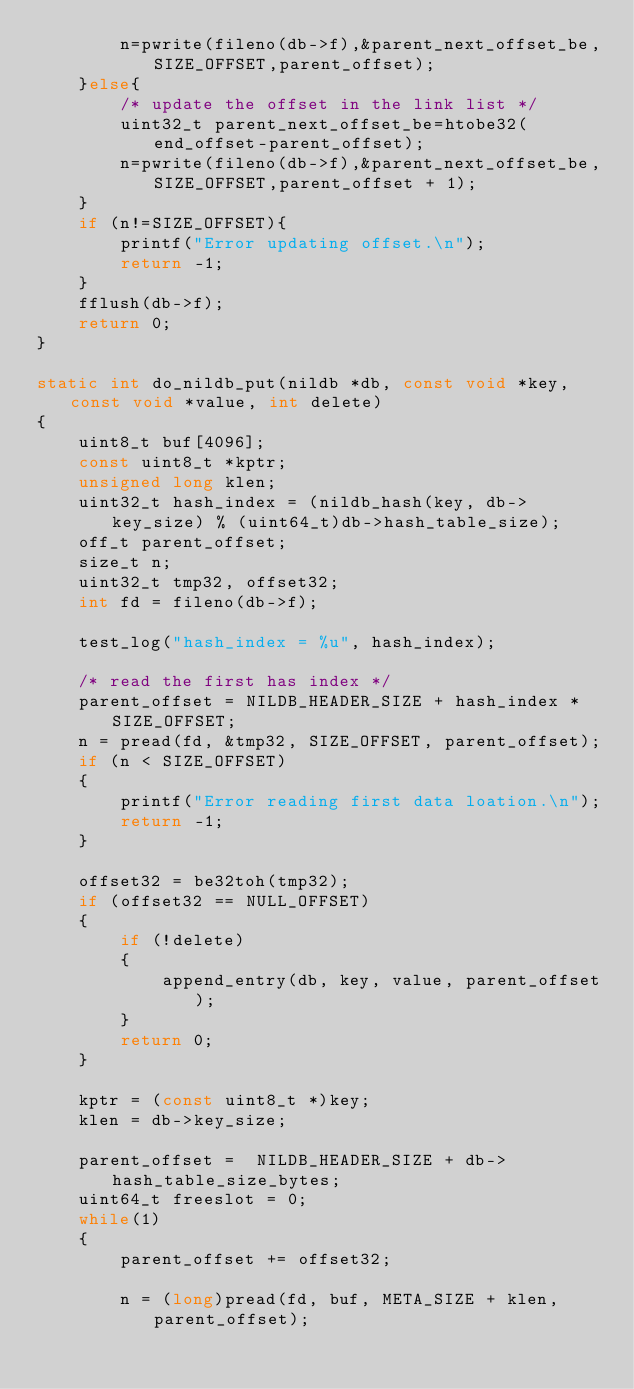Convert code to text. <code><loc_0><loc_0><loc_500><loc_500><_C_>		n=pwrite(fileno(db->f),&parent_next_offset_be,SIZE_OFFSET,parent_offset);
	}else{
		/* update the offset in the link list */
		uint32_t parent_next_offset_be=htobe32(end_offset-parent_offset);
		n=pwrite(fileno(db->f),&parent_next_offset_be,SIZE_OFFSET,parent_offset + 1);
	}
	if (n!=SIZE_OFFSET){
		printf("Error updating offset.\n");
		return -1;
	}
	fflush(db->f);
	return 0;
}

static int do_nildb_put(nildb *db, const void *key, const void *value, int delete)
{
	uint8_t buf[4096];
	const uint8_t *kptr;
	unsigned long klen;
	uint32_t hash_index = (nildb_hash(key, db->key_size) % (uint64_t)db->hash_table_size);
	off_t parent_offset;
	size_t n;
	uint32_t tmp32, offset32;
	int fd = fileno(db->f);

	test_log("hash_index = %u", hash_index);

	/* read the first has index */
	parent_offset = NILDB_HEADER_SIZE + hash_index * SIZE_OFFSET;
	n = pread(fd, &tmp32, SIZE_OFFSET, parent_offset);
	if (n < SIZE_OFFSET)
	{
		printf("Error reading first data loation.\n");
		return -1;
	}

	offset32 = be32toh(tmp32);
	if (offset32 == NULL_OFFSET)
	{
		if (!delete)
		{
			append_entry(db, key, value, parent_offset);
		}
		return 0;
	}

	kptr = (const uint8_t *)key;
	klen = db->key_size;

	parent_offset =  NILDB_HEADER_SIZE + db->hash_table_size_bytes;
	uint64_t freeslot = 0;
	while(1)
	{
		parent_offset += offset32;

		n = (long)pread(fd, buf, META_SIZE + klen, parent_offset);</code> 